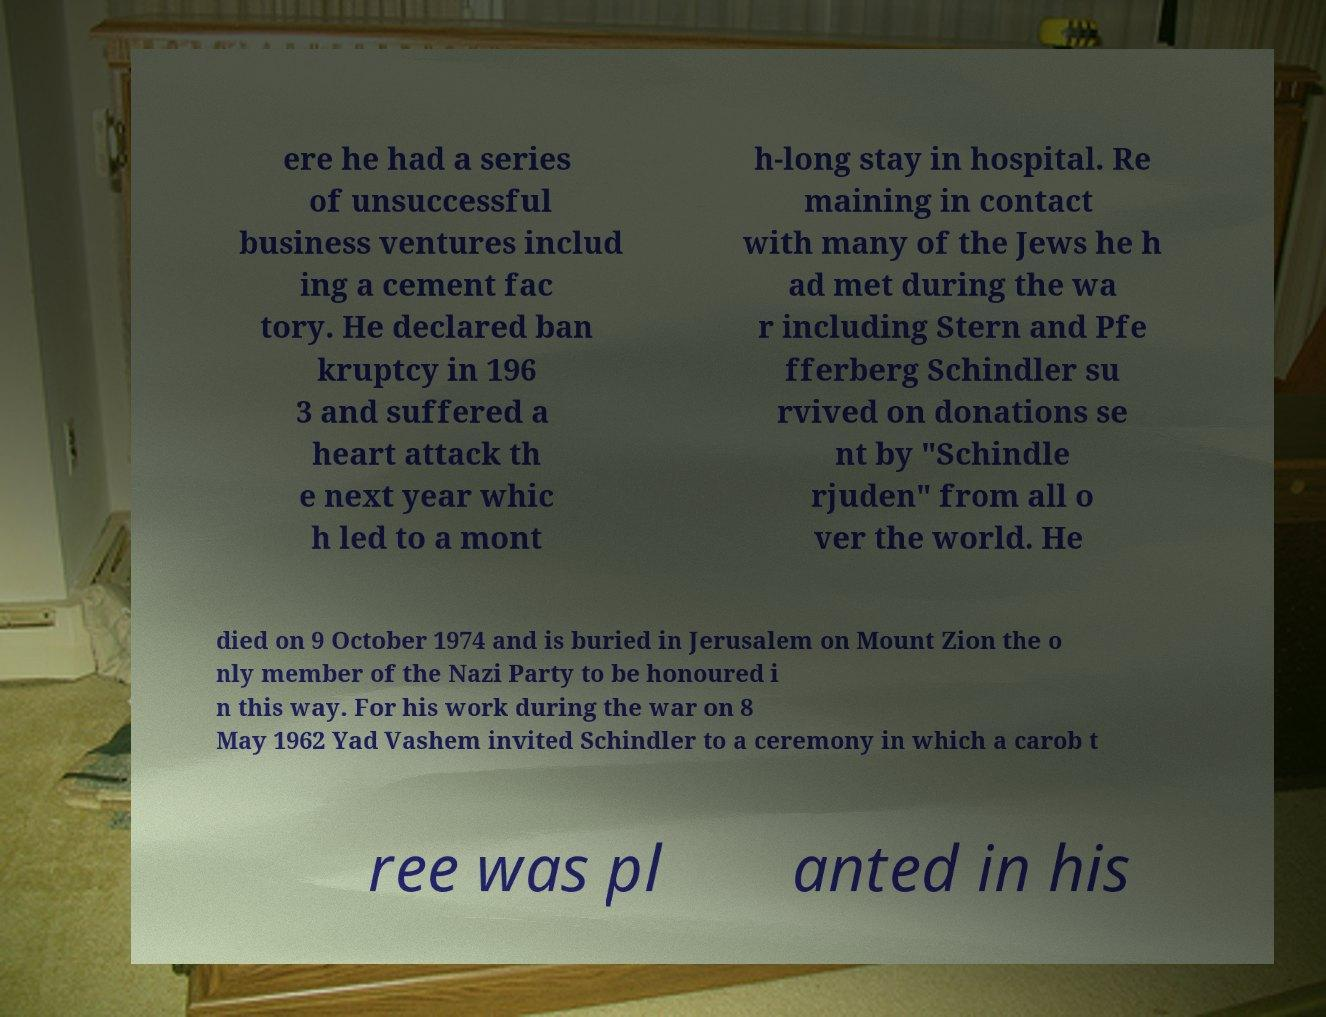What messages or text are displayed in this image? I need them in a readable, typed format. ere he had a series of unsuccessful business ventures includ ing a cement fac tory. He declared ban kruptcy in 196 3 and suffered a heart attack th e next year whic h led to a mont h-long stay in hospital. Re maining in contact with many of the Jews he h ad met during the wa r including Stern and Pfe fferberg Schindler su rvived on donations se nt by "Schindle rjuden" from all o ver the world. He died on 9 October 1974 and is buried in Jerusalem on Mount Zion the o nly member of the Nazi Party to be honoured i n this way. For his work during the war on 8 May 1962 Yad Vashem invited Schindler to a ceremony in which a carob t ree was pl anted in his 